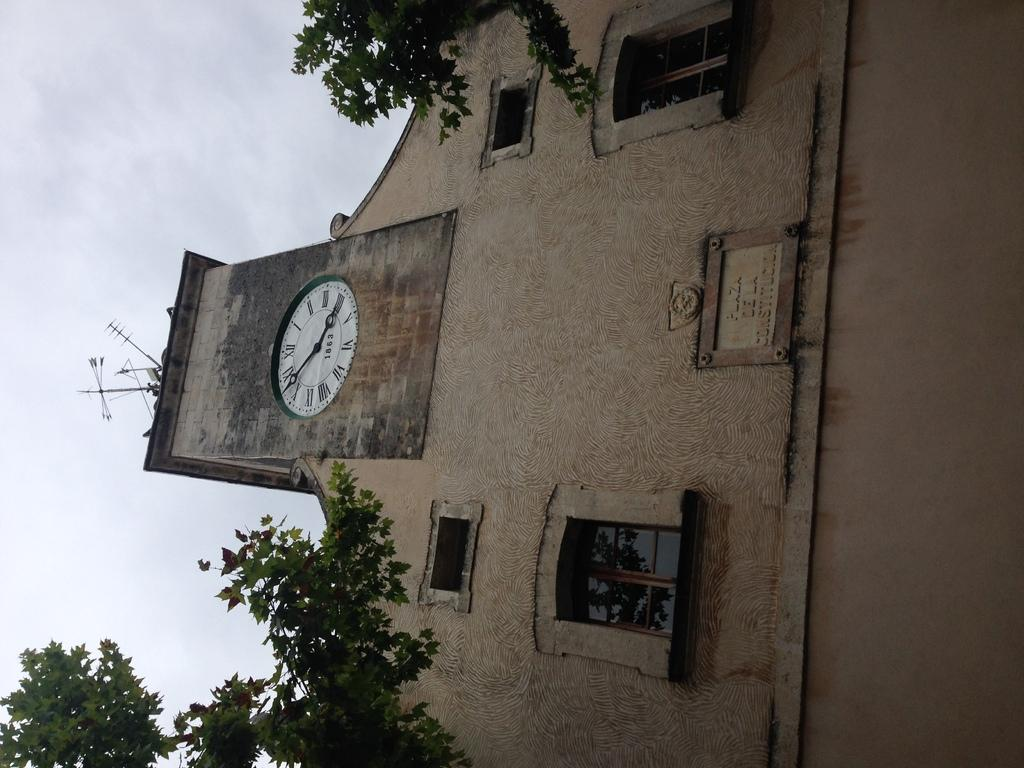Provide a one-sentence caption for the provided image. A clock that shows it to be seven until four with 1863 on the clock face. 